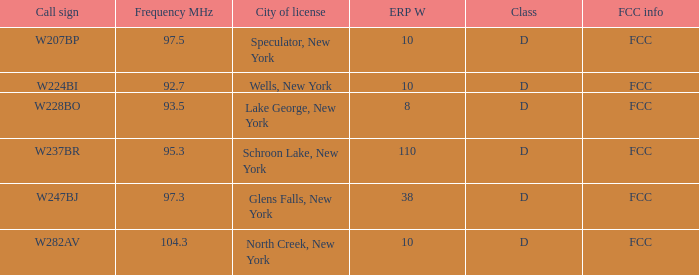Could you parse the entire table? {'header': ['Call sign', 'Frequency MHz', 'City of license', 'ERP W', 'Class', 'FCC info'], 'rows': [['W207BP', '97.5', 'Speculator, New York', '10', 'D', 'FCC'], ['W224BI', '92.7', 'Wells, New York', '10', 'D', 'FCC'], ['W228BO', '93.5', 'Lake George, New York', '8', 'D', 'FCC'], ['W237BR', '95.3', 'Schroon Lake, New York', '110', 'D', 'FCC'], ['W247BJ', '97.3', 'Glens Falls, New York', '38', 'D', 'FCC'], ['W282AV', '104.3', 'North Creek, New York', '10', 'D', 'FCC']]} Name the ERP W for glens falls, new york 38.0. 